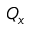Convert formula to latex. <formula><loc_0><loc_0><loc_500><loc_500>Q _ { x }</formula> 